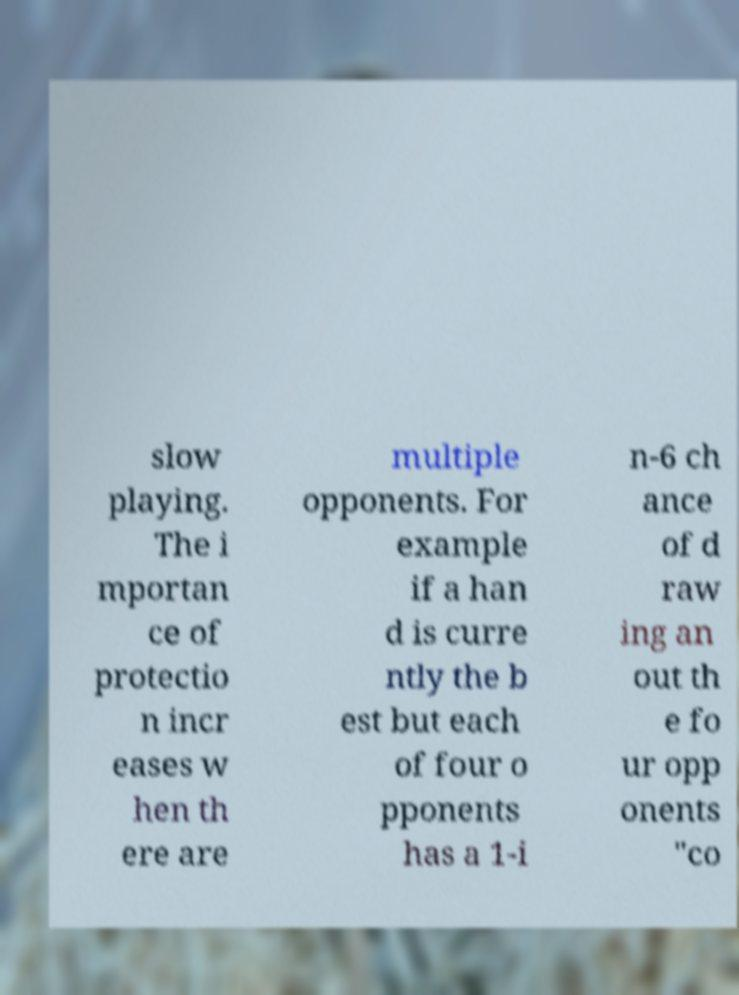Please identify and transcribe the text found in this image. slow playing. The i mportan ce of protectio n incr eases w hen th ere are multiple opponents. For example if a han d is curre ntly the b est but each of four o pponents has a 1-i n-6 ch ance of d raw ing an out th e fo ur opp onents "co 